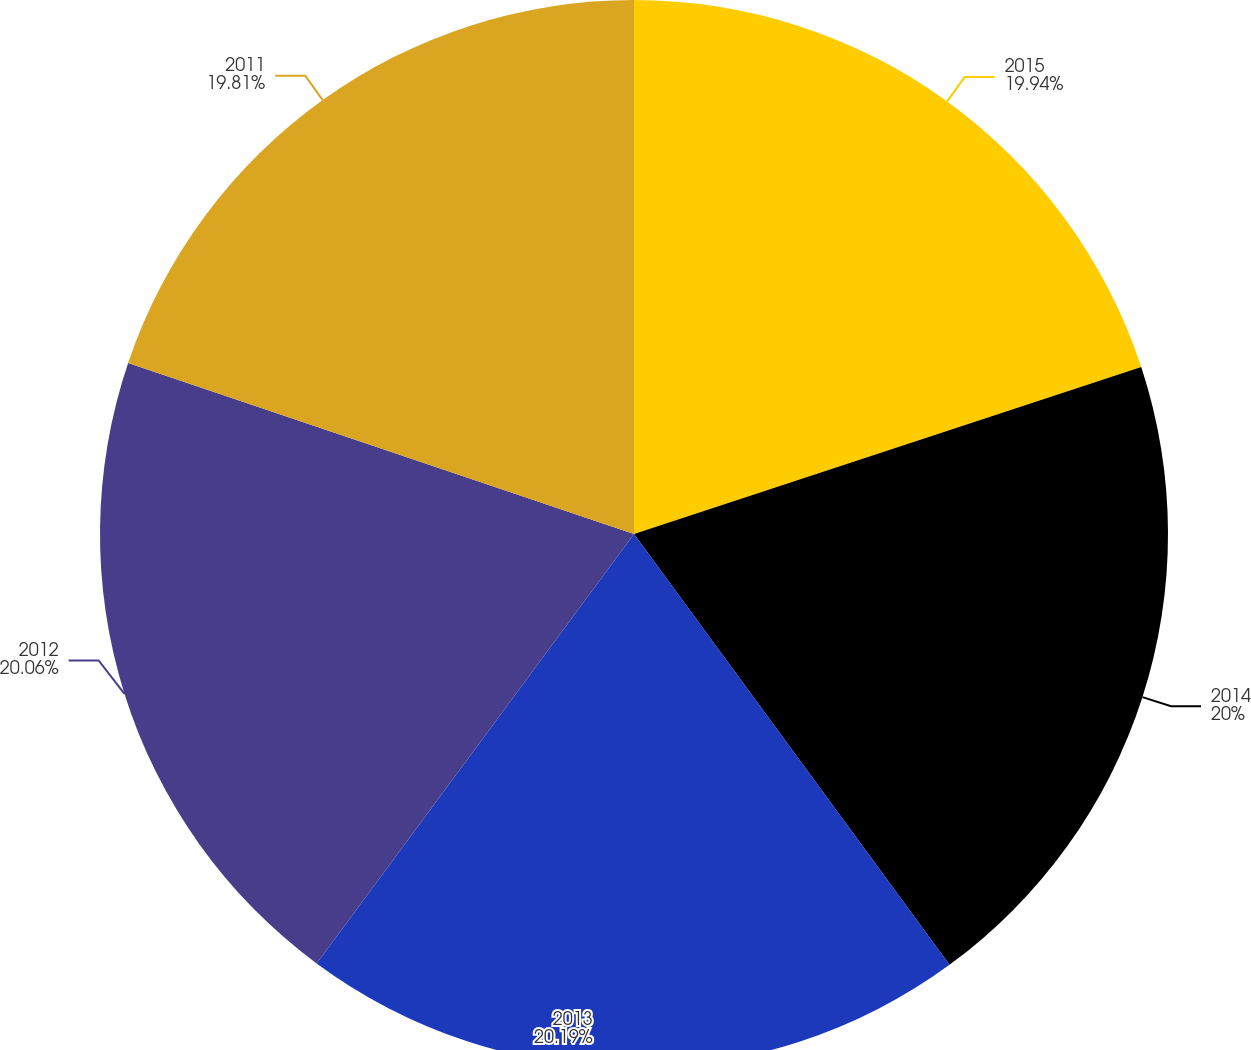<chart> <loc_0><loc_0><loc_500><loc_500><pie_chart><fcel>2015<fcel>2014<fcel>2013<fcel>2012<fcel>2011<nl><fcel>19.94%<fcel>20.0%<fcel>20.19%<fcel>20.06%<fcel>19.81%<nl></chart> 